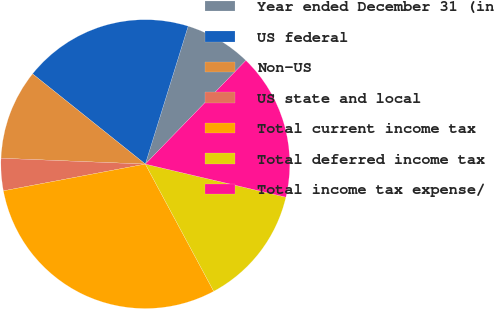Convert chart to OTSL. <chart><loc_0><loc_0><loc_500><loc_500><pie_chart><fcel>Year ended December 31 (in<fcel>US federal<fcel>Non-US<fcel>US state and local<fcel>Total current income tax<fcel>Total deferred income tax<fcel>Total income tax expense/<nl><fcel>7.47%<fcel>19.05%<fcel>10.1%<fcel>3.61%<fcel>29.89%<fcel>13.47%<fcel>16.42%<nl></chart> 